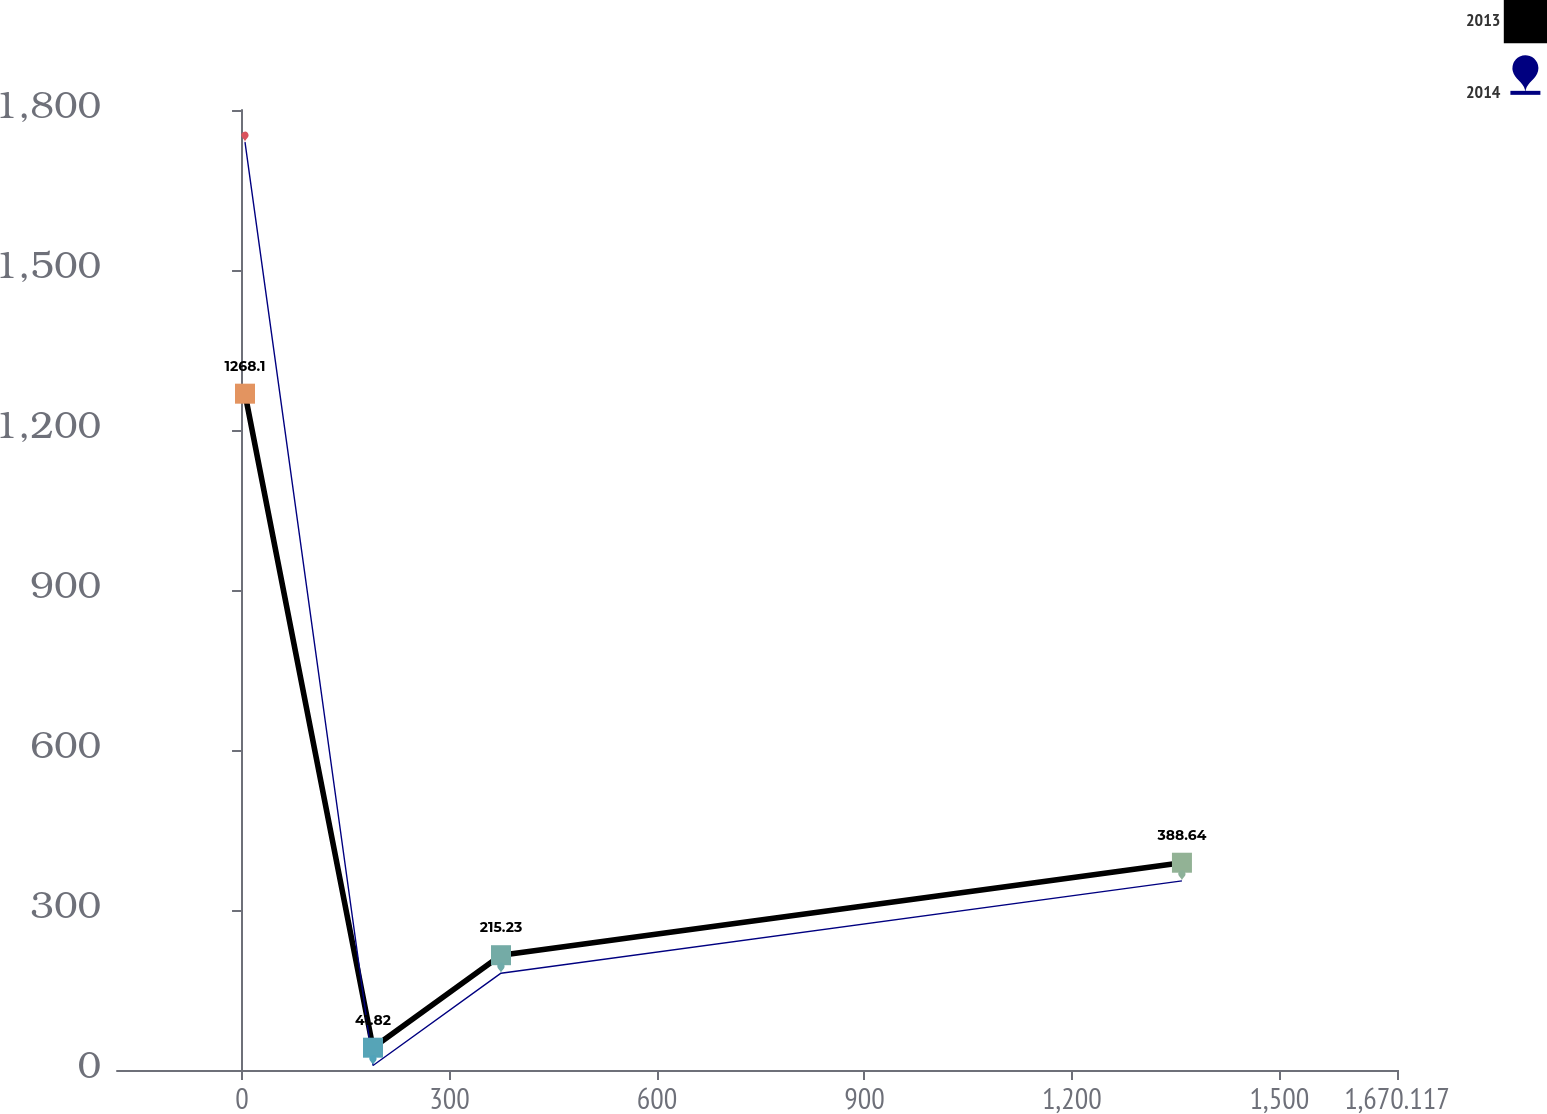<chart> <loc_0><loc_0><loc_500><loc_500><line_chart><ecel><fcel>2013<fcel>2014<nl><fcel>4.28<fcel>1268.1<fcel>1739.69<nl><fcel>189.37<fcel>41.82<fcel>8.39<nl><fcel>374.46<fcel>215.23<fcel>181.52<nl><fcel>1359.13<fcel>388.64<fcel>354.65<nl><fcel>1855.21<fcel>1775.89<fcel>1527.5<nl></chart> 